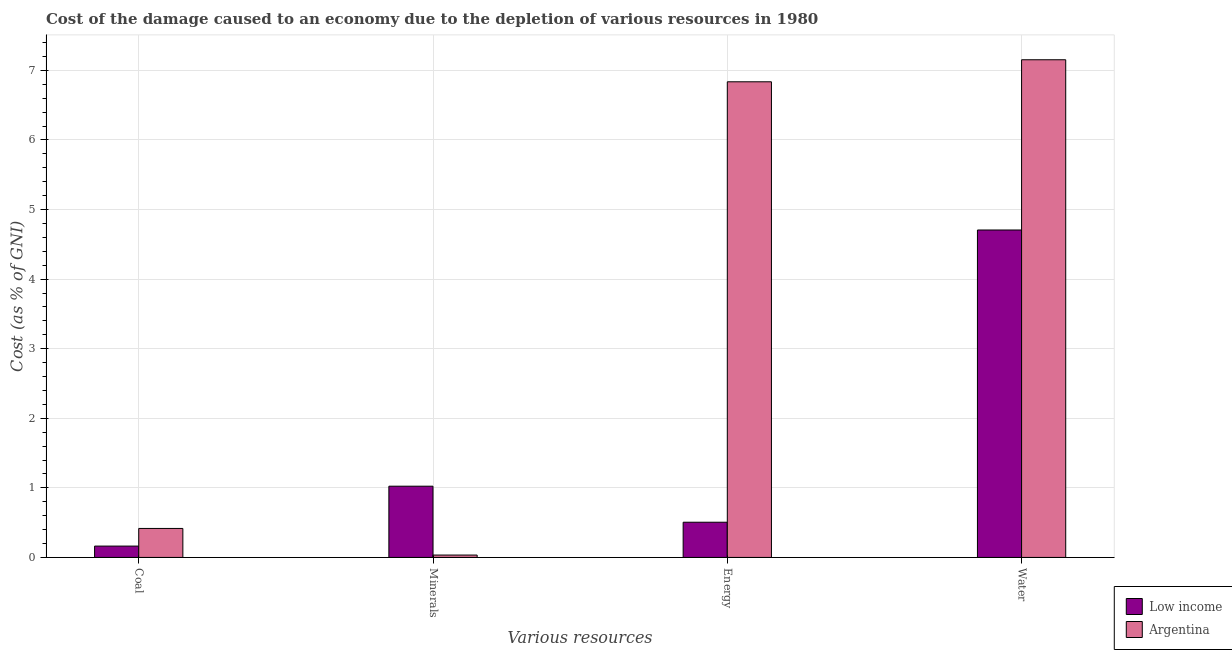How many different coloured bars are there?
Provide a succinct answer. 2. How many groups of bars are there?
Provide a succinct answer. 4. Are the number of bars on each tick of the X-axis equal?
Provide a short and direct response. Yes. How many bars are there on the 3rd tick from the left?
Your answer should be very brief. 2. What is the label of the 3rd group of bars from the left?
Make the answer very short. Energy. What is the cost of damage due to depletion of coal in Argentina?
Provide a short and direct response. 0.42. Across all countries, what is the maximum cost of damage due to depletion of minerals?
Provide a succinct answer. 1.02. Across all countries, what is the minimum cost of damage due to depletion of minerals?
Offer a very short reply. 0.03. What is the total cost of damage due to depletion of water in the graph?
Your answer should be very brief. 11.86. What is the difference between the cost of damage due to depletion of coal in Argentina and that in Low income?
Your answer should be compact. 0.25. What is the difference between the cost of damage due to depletion of coal in Low income and the cost of damage due to depletion of water in Argentina?
Give a very brief answer. -6.99. What is the average cost of damage due to depletion of minerals per country?
Provide a succinct answer. 0.53. What is the difference between the cost of damage due to depletion of energy and cost of damage due to depletion of water in Low income?
Provide a succinct answer. -4.2. In how many countries, is the cost of damage due to depletion of energy greater than 7.2 %?
Your answer should be compact. 0. What is the ratio of the cost of damage due to depletion of water in Argentina to that in Low income?
Keep it short and to the point. 1.52. Is the cost of damage due to depletion of energy in Low income less than that in Argentina?
Give a very brief answer. Yes. Is the difference between the cost of damage due to depletion of water in Argentina and Low income greater than the difference between the cost of damage due to depletion of minerals in Argentina and Low income?
Your answer should be compact. Yes. What is the difference between the highest and the second highest cost of damage due to depletion of energy?
Offer a terse response. 6.33. What is the difference between the highest and the lowest cost of damage due to depletion of coal?
Offer a very short reply. 0.25. Is it the case that in every country, the sum of the cost of damage due to depletion of minerals and cost of damage due to depletion of energy is greater than the sum of cost of damage due to depletion of coal and cost of damage due to depletion of water?
Offer a terse response. Yes. What does the 1st bar from the left in Energy represents?
Your response must be concise. Low income. What does the 1st bar from the right in Coal represents?
Provide a succinct answer. Argentina. Is it the case that in every country, the sum of the cost of damage due to depletion of coal and cost of damage due to depletion of minerals is greater than the cost of damage due to depletion of energy?
Make the answer very short. No. Are all the bars in the graph horizontal?
Your answer should be compact. No. How many countries are there in the graph?
Your response must be concise. 2. What is the difference between two consecutive major ticks on the Y-axis?
Your answer should be compact. 1. Does the graph contain any zero values?
Make the answer very short. No. Does the graph contain grids?
Keep it short and to the point. Yes. Where does the legend appear in the graph?
Provide a short and direct response. Bottom right. What is the title of the graph?
Offer a very short reply. Cost of the damage caused to an economy due to the depletion of various resources in 1980 . Does "Lower middle income" appear as one of the legend labels in the graph?
Keep it short and to the point. No. What is the label or title of the X-axis?
Keep it short and to the point. Various resources. What is the label or title of the Y-axis?
Offer a very short reply. Cost (as % of GNI). What is the Cost (as % of GNI) in Low income in Coal?
Provide a succinct answer. 0.16. What is the Cost (as % of GNI) of Argentina in Coal?
Offer a terse response. 0.42. What is the Cost (as % of GNI) of Low income in Minerals?
Provide a short and direct response. 1.02. What is the Cost (as % of GNI) in Argentina in Minerals?
Your response must be concise. 0.03. What is the Cost (as % of GNI) of Low income in Energy?
Give a very brief answer. 0.51. What is the Cost (as % of GNI) of Argentina in Energy?
Keep it short and to the point. 6.84. What is the Cost (as % of GNI) in Low income in Water?
Your answer should be compact. 4.71. What is the Cost (as % of GNI) in Argentina in Water?
Offer a terse response. 7.15. Across all Various resources, what is the maximum Cost (as % of GNI) in Low income?
Give a very brief answer. 4.71. Across all Various resources, what is the maximum Cost (as % of GNI) in Argentina?
Offer a terse response. 7.15. Across all Various resources, what is the minimum Cost (as % of GNI) in Low income?
Offer a terse response. 0.16. Across all Various resources, what is the minimum Cost (as % of GNI) of Argentina?
Offer a very short reply. 0.03. What is the total Cost (as % of GNI) of Low income in the graph?
Your answer should be very brief. 6.4. What is the total Cost (as % of GNI) in Argentina in the graph?
Your answer should be very brief. 14.44. What is the difference between the Cost (as % of GNI) of Low income in Coal and that in Minerals?
Your answer should be very brief. -0.86. What is the difference between the Cost (as % of GNI) in Argentina in Coal and that in Minerals?
Keep it short and to the point. 0.38. What is the difference between the Cost (as % of GNI) in Low income in Coal and that in Energy?
Keep it short and to the point. -0.34. What is the difference between the Cost (as % of GNI) of Argentina in Coal and that in Energy?
Your answer should be compact. -6.42. What is the difference between the Cost (as % of GNI) in Low income in Coal and that in Water?
Your answer should be compact. -4.54. What is the difference between the Cost (as % of GNI) of Argentina in Coal and that in Water?
Make the answer very short. -6.74. What is the difference between the Cost (as % of GNI) in Low income in Minerals and that in Energy?
Provide a succinct answer. 0.52. What is the difference between the Cost (as % of GNI) in Argentina in Minerals and that in Energy?
Your response must be concise. -6.8. What is the difference between the Cost (as % of GNI) in Low income in Minerals and that in Water?
Provide a short and direct response. -3.68. What is the difference between the Cost (as % of GNI) of Argentina in Minerals and that in Water?
Give a very brief answer. -7.12. What is the difference between the Cost (as % of GNI) of Low income in Energy and that in Water?
Provide a succinct answer. -4.2. What is the difference between the Cost (as % of GNI) of Argentina in Energy and that in Water?
Offer a very short reply. -0.32. What is the difference between the Cost (as % of GNI) in Low income in Coal and the Cost (as % of GNI) in Argentina in Minerals?
Offer a very short reply. 0.13. What is the difference between the Cost (as % of GNI) of Low income in Coal and the Cost (as % of GNI) of Argentina in Energy?
Ensure brevity in your answer.  -6.67. What is the difference between the Cost (as % of GNI) in Low income in Coal and the Cost (as % of GNI) in Argentina in Water?
Your answer should be compact. -6.99. What is the difference between the Cost (as % of GNI) of Low income in Minerals and the Cost (as % of GNI) of Argentina in Energy?
Give a very brief answer. -5.81. What is the difference between the Cost (as % of GNI) in Low income in Minerals and the Cost (as % of GNI) in Argentina in Water?
Provide a succinct answer. -6.13. What is the difference between the Cost (as % of GNI) in Low income in Energy and the Cost (as % of GNI) in Argentina in Water?
Your answer should be very brief. -6.65. What is the average Cost (as % of GNI) in Low income per Various resources?
Offer a terse response. 1.6. What is the average Cost (as % of GNI) in Argentina per Various resources?
Give a very brief answer. 3.61. What is the difference between the Cost (as % of GNI) of Low income and Cost (as % of GNI) of Argentina in Coal?
Offer a terse response. -0.25. What is the difference between the Cost (as % of GNI) in Low income and Cost (as % of GNI) in Argentina in Energy?
Make the answer very short. -6.33. What is the difference between the Cost (as % of GNI) of Low income and Cost (as % of GNI) of Argentina in Water?
Ensure brevity in your answer.  -2.45. What is the ratio of the Cost (as % of GNI) of Low income in Coal to that in Minerals?
Your answer should be very brief. 0.16. What is the ratio of the Cost (as % of GNI) of Argentina in Coal to that in Minerals?
Provide a succinct answer. 12.21. What is the ratio of the Cost (as % of GNI) in Low income in Coal to that in Energy?
Ensure brevity in your answer.  0.32. What is the ratio of the Cost (as % of GNI) in Argentina in Coal to that in Energy?
Your answer should be compact. 0.06. What is the ratio of the Cost (as % of GNI) of Low income in Coal to that in Water?
Your answer should be very brief. 0.03. What is the ratio of the Cost (as % of GNI) in Argentina in Coal to that in Water?
Offer a terse response. 0.06. What is the ratio of the Cost (as % of GNI) in Low income in Minerals to that in Energy?
Provide a short and direct response. 2.02. What is the ratio of the Cost (as % of GNI) of Argentina in Minerals to that in Energy?
Ensure brevity in your answer.  0.01. What is the ratio of the Cost (as % of GNI) in Low income in Minerals to that in Water?
Ensure brevity in your answer.  0.22. What is the ratio of the Cost (as % of GNI) of Argentina in Minerals to that in Water?
Your response must be concise. 0. What is the ratio of the Cost (as % of GNI) in Low income in Energy to that in Water?
Offer a terse response. 0.11. What is the ratio of the Cost (as % of GNI) of Argentina in Energy to that in Water?
Offer a very short reply. 0.96. What is the difference between the highest and the second highest Cost (as % of GNI) in Low income?
Your answer should be very brief. 3.68. What is the difference between the highest and the second highest Cost (as % of GNI) in Argentina?
Give a very brief answer. 0.32. What is the difference between the highest and the lowest Cost (as % of GNI) of Low income?
Provide a succinct answer. 4.54. What is the difference between the highest and the lowest Cost (as % of GNI) of Argentina?
Make the answer very short. 7.12. 